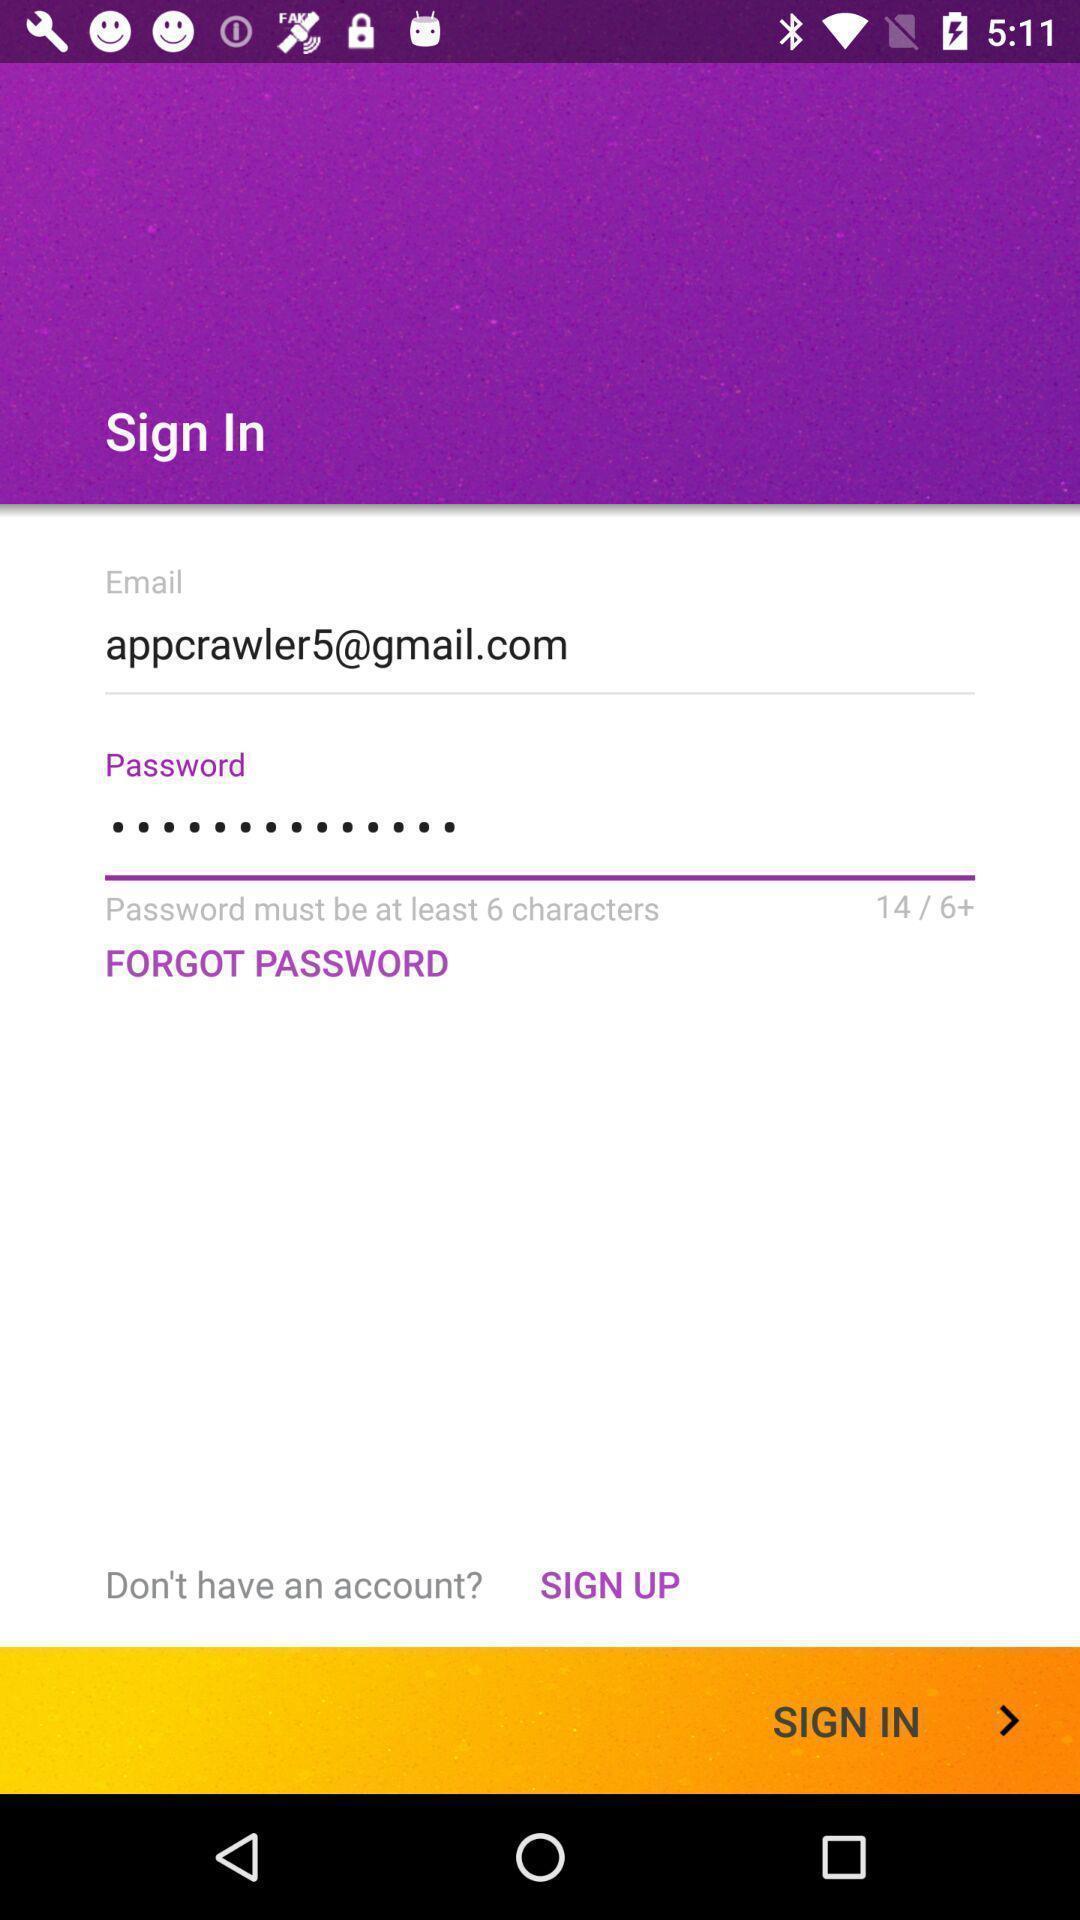Describe the visual elements of this screenshot. Sign-in page of a music app. 